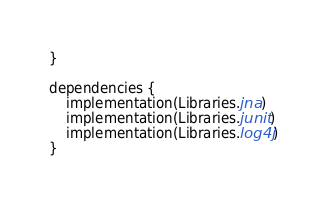Convert code to text. <code><loc_0><loc_0><loc_500><loc_500><_Kotlin_>}

dependencies {
    implementation(Libraries.jna)
    implementation(Libraries.junit)
    implementation(Libraries.log4j)
}</code> 